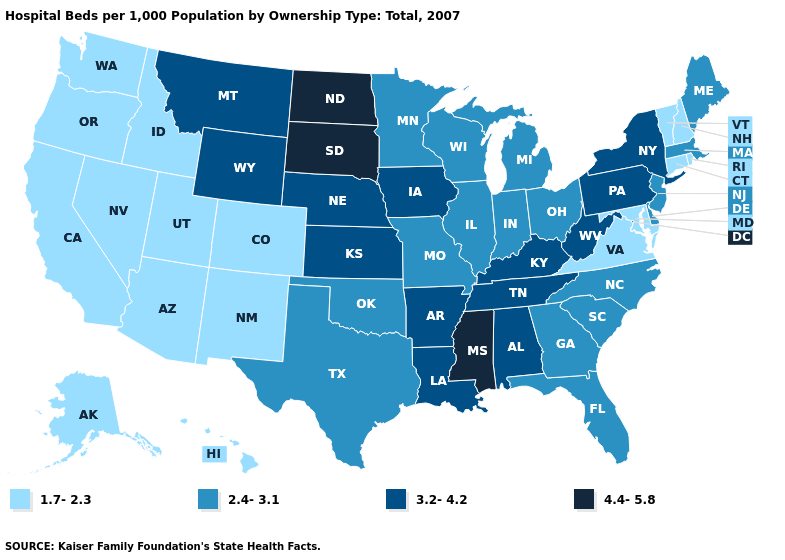Among the states that border Texas , does Arkansas have the lowest value?
Write a very short answer. No. Among the states that border Texas , does New Mexico have the highest value?
Concise answer only. No. What is the value of North Dakota?
Short answer required. 4.4-5.8. Is the legend a continuous bar?
Give a very brief answer. No. What is the value of Ohio?
Give a very brief answer. 2.4-3.1. What is the value of Oklahoma?
Write a very short answer. 2.4-3.1. How many symbols are there in the legend?
Short answer required. 4. Which states have the lowest value in the Northeast?
Give a very brief answer. Connecticut, New Hampshire, Rhode Island, Vermont. What is the value of Nebraska?
Concise answer only. 3.2-4.2. Does New Jersey have the same value as Illinois?
Quick response, please. Yes. What is the highest value in states that border Wyoming?
Keep it brief. 4.4-5.8. Name the states that have a value in the range 4.4-5.8?
Short answer required. Mississippi, North Dakota, South Dakota. Which states have the highest value in the USA?
Keep it brief. Mississippi, North Dakota, South Dakota. Does the map have missing data?
Quick response, please. No. How many symbols are there in the legend?
Give a very brief answer. 4. 